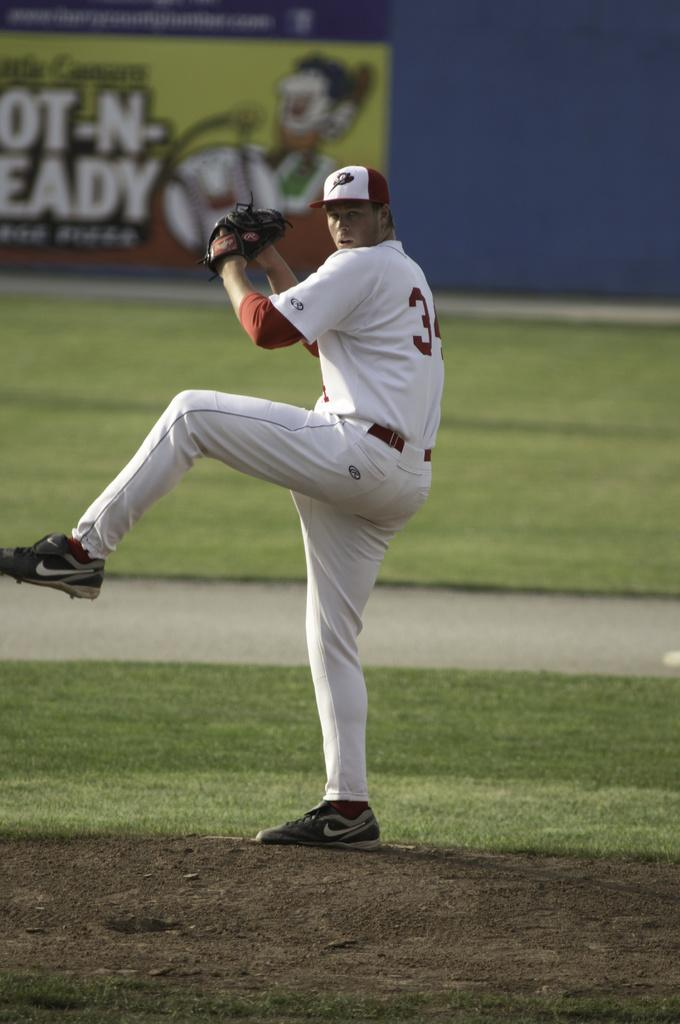<image>
Give a short and clear explanation of the subsequent image. Baseball player wearing a number 3 getting ready to pitch. 